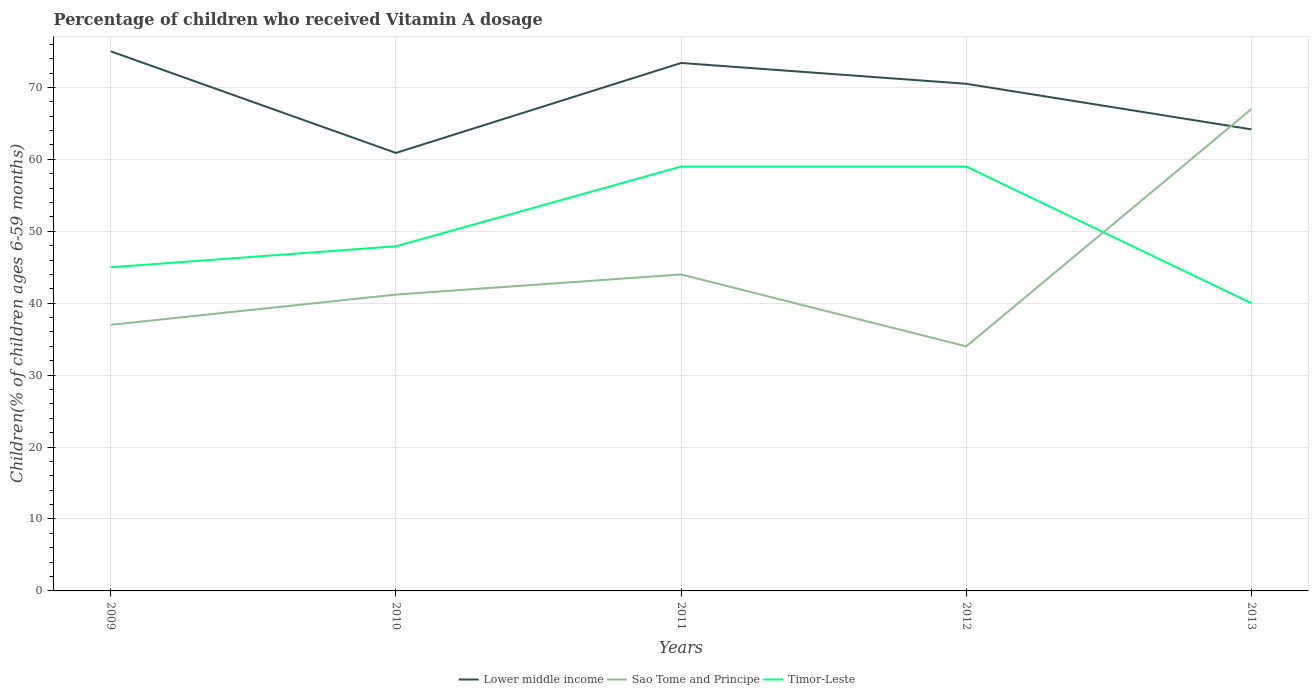Does the line corresponding to Sao Tome and Principe intersect with the line corresponding to Timor-Leste?
Ensure brevity in your answer.  Yes. In which year was the percentage of children who received Vitamin A dosage in Sao Tome and Principe maximum?
Your answer should be compact. 2012. What is the total percentage of children who received Vitamin A dosage in Timor-Leste in the graph?
Your answer should be very brief. 19. What is the difference between the highest and the second highest percentage of children who received Vitamin A dosage in Lower middle income?
Keep it short and to the point. 14.13. What is the difference between the highest and the lowest percentage of children who received Vitamin A dosage in Sao Tome and Principe?
Provide a succinct answer. 1. How many lines are there?
Offer a terse response. 3. What is the difference between two consecutive major ticks on the Y-axis?
Offer a very short reply. 10. Does the graph contain any zero values?
Offer a very short reply. No. Does the graph contain grids?
Give a very brief answer. Yes. How are the legend labels stacked?
Give a very brief answer. Horizontal. What is the title of the graph?
Keep it short and to the point. Percentage of children who received Vitamin A dosage. Does "Tanzania" appear as one of the legend labels in the graph?
Provide a short and direct response. No. What is the label or title of the X-axis?
Keep it short and to the point. Years. What is the label or title of the Y-axis?
Offer a terse response. Children(% of children ages 6-59 months). What is the Children(% of children ages 6-59 months) of Lower middle income in 2009?
Provide a short and direct response. 75.02. What is the Children(% of children ages 6-59 months) of Sao Tome and Principe in 2009?
Offer a very short reply. 37. What is the Children(% of children ages 6-59 months) of Lower middle income in 2010?
Provide a succinct answer. 60.9. What is the Children(% of children ages 6-59 months) of Sao Tome and Principe in 2010?
Give a very brief answer. 41.2. What is the Children(% of children ages 6-59 months) in Timor-Leste in 2010?
Your answer should be very brief. 47.91. What is the Children(% of children ages 6-59 months) in Lower middle income in 2011?
Your answer should be very brief. 73.4. What is the Children(% of children ages 6-59 months) in Sao Tome and Principe in 2011?
Keep it short and to the point. 44. What is the Children(% of children ages 6-59 months) of Lower middle income in 2012?
Give a very brief answer. 70.51. What is the Children(% of children ages 6-59 months) of Sao Tome and Principe in 2012?
Provide a succinct answer. 34. What is the Children(% of children ages 6-59 months) in Lower middle income in 2013?
Your response must be concise. 64.17. What is the Children(% of children ages 6-59 months) in Sao Tome and Principe in 2013?
Ensure brevity in your answer.  67. What is the Children(% of children ages 6-59 months) in Timor-Leste in 2013?
Keep it short and to the point. 40. Across all years, what is the maximum Children(% of children ages 6-59 months) in Lower middle income?
Your answer should be very brief. 75.02. Across all years, what is the minimum Children(% of children ages 6-59 months) in Lower middle income?
Provide a short and direct response. 60.9. Across all years, what is the minimum Children(% of children ages 6-59 months) in Sao Tome and Principe?
Keep it short and to the point. 34. What is the total Children(% of children ages 6-59 months) of Lower middle income in the graph?
Provide a succinct answer. 344.01. What is the total Children(% of children ages 6-59 months) in Sao Tome and Principe in the graph?
Make the answer very short. 223.2. What is the total Children(% of children ages 6-59 months) of Timor-Leste in the graph?
Provide a short and direct response. 250.91. What is the difference between the Children(% of children ages 6-59 months) in Lower middle income in 2009 and that in 2010?
Provide a succinct answer. 14.13. What is the difference between the Children(% of children ages 6-59 months) in Sao Tome and Principe in 2009 and that in 2010?
Your answer should be compact. -4.2. What is the difference between the Children(% of children ages 6-59 months) of Timor-Leste in 2009 and that in 2010?
Offer a very short reply. -2.91. What is the difference between the Children(% of children ages 6-59 months) in Lower middle income in 2009 and that in 2011?
Offer a terse response. 1.62. What is the difference between the Children(% of children ages 6-59 months) in Timor-Leste in 2009 and that in 2011?
Offer a terse response. -14. What is the difference between the Children(% of children ages 6-59 months) in Lower middle income in 2009 and that in 2012?
Provide a succinct answer. 4.51. What is the difference between the Children(% of children ages 6-59 months) in Timor-Leste in 2009 and that in 2012?
Provide a succinct answer. -14. What is the difference between the Children(% of children ages 6-59 months) in Lower middle income in 2009 and that in 2013?
Keep it short and to the point. 10.85. What is the difference between the Children(% of children ages 6-59 months) in Sao Tome and Principe in 2009 and that in 2013?
Give a very brief answer. -30. What is the difference between the Children(% of children ages 6-59 months) in Lower middle income in 2010 and that in 2011?
Keep it short and to the point. -12.51. What is the difference between the Children(% of children ages 6-59 months) of Sao Tome and Principe in 2010 and that in 2011?
Offer a terse response. -2.8. What is the difference between the Children(% of children ages 6-59 months) in Timor-Leste in 2010 and that in 2011?
Provide a succinct answer. -11.09. What is the difference between the Children(% of children ages 6-59 months) in Lower middle income in 2010 and that in 2012?
Provide a short and direct response. -9.62. What is the difference between the Children(% of children ages 6-59 months) in Sao Tome and Principe in 2010 and that in 2012?
Keep it short and to the point. 7.2. What is the difference between the Children(% of children ages 6-59 months) in Timor-Leste in 2010 and that in 2012?
Your answer should be very brief. -11.09. What is the difference between the Children(% of children ages 6-59 months) of Lower middle income in 2010 and that in 2013?
Ensure brevity in your answer.  -3.28. What is the difference between the Children(% of children ages 6-59 months) of Sao Tome and Principe in 2010 and that in 2013?
Make the answer very short. -25.8. What is the difference between the Children(% of children ages 6-59 months) of Timor-Leste in 2010 and that in 2013?
Make the answer very short. 7.91. What is the difference between the Children(% of children ages 6-59 months) of Lower middle income in 2011 and that in 2012?
Give a very brief answer. 2.89. What is the difference between the Children(% of children ages 6-59 months) of Lower middle income in 2011 and that in 2013?
Your response must be concise. 9.23. What is the difference between the Children(% of children ages 6-59 months) of Timor-Leste in 2011 and that in 2013?
Provide a succinct answer. 19. What is the difference between the Children(% of children ages 6-59 months) in Lower middle income in 2012 and that in 2013?
Your answer should be very brief. 6.34. What is the difference between the Children(% of children ages 6-59 months) of Sao Tome and Principe in 2012 and that in 2013?
Make the answer very short. -33. What is the difference between the Children(% of children ages 6-59 months) of Timor-Leste in 2012 and that in 2013?
Your answer should be compact. 19. What is the difference between the Children(% of children ages 6-59 months) of Lower middle income in 2009 and the Children(% of children ages 6-59 months) of Sao Tome and Principe in 2010?
Offer a very short reply. 33.82. What is the difference between the Children(% of children ages 6-59 months) in Lower middle income in 2009 and the Children(% of children ages 6-59 months) in Timor-Leste in 2010?
Make the answer very short. 27.11. What is the difference between the Children(% of children ages 6-59 months) in Sao Tome and Principe in 2009 and the Children(% of children ages 6-59 months) in Timor-Leste in 2010?
Make the answer very short. -10.91. What is the difference between the Children(% of children ages 6-59 months) of Lower middle income in 2009 and the Children(% of children ages 6-59 months) of Sao Tome and Principe in 2011?
Offer a very short reply. 31.02. What is the difference between the Children(% of children ages 6-59 months) in Lower middle income in 2009 and the Children(% of children ages 6-59 months) in Timor-Leste in 2011?
Offer a very short reply. 16.02. What is the difference between the Children(% of children ages 6-59 months) of Sao Tome and Principe in 2009 and the Children(% of children ages 6-59 months) of Timor-Leste in 2011?
Your response must be concise. -22. What is the difference between the Children(% of children ages 6-59 months) of Lower middle income in 2009 and the Children(% of children ages 6-59 months) of Sao Tome and Principe in 2012?
Give a very brief answer. 41.02. What is the difference between the Children(% of children ages 6-59 months) in Lower middle income in 2009 and the Children(% of children ages 6-59 months) in Timor-Leste in 2012?
Your answer should be very brief. 16.02. What is the difference between the Children(% of children ages 6-59 months) in Sao Tome and Principe in 2009 and the Children(% of children ages 6-59 months) in Timor-Leste in 2012?
Offer a very short reply. -22. What is the difference between the Children(% of children ages 6-59 months) of Lower middle income in 2009 and the Children(% of children ages 6-59 months) of Sao Tome and Principe in 2013?
Keep it short and to the point. 8.02. What is the difference between the Children(% of children ages 6-59 months) of Lower middle income in 2009 and the Children(% of children ages 6-59 months) of Timor-Leste in 2013?
Ensure brevity in your answer.  35.02. What is the difference between the Children(% of children ages 6-59 months) of Sao Tome and Principe in 2009 and the Children(% of children ages 6-59 months) of Timor-Leste in 2013?
Keep it short and to the point. -3. What is the difference between the Children(% of children ages 6-59 months) of Lower middle income in 2010 and the Children(% of children ages 6-59 months) of Sao Tome and Principe in 2011?
Your answer should be very brief. 16.9. What is the difference between the Children(% of children ages 6-59 months) in Lower middle income in 2010 and the Children(% of children ages 6-59 months) in Timor-Leste in 2011?
Keep it short and to the point. 1.9. What is the difference between the Children(% of children ages 6-59 months) of Sao Tome and Principe in 2010 and the Children(% of children ages 6-59 months) of Timor-Leste in 2011?
Provide a short and direct response. -17.8. What is the difference between the Children(% of children ages 6-59 months) of Lower middle income in 2010 and the Children(% of children ages 6-59 months) of Sao Tome and Principe in 2012?
Offer a terse response. 26.9. What is the difference between the Children(% of children ages 6-59 months) in Lower middle income in 2010 and the Children(% of children ages 6-59 months) in Timor-Leste in 2012?
Keep it short and to the point. 1.9. What is the difference between the Children(% of children ages 6-59 months) in Sao Tome and Principe in 2010 and the Children(% of children ages 6-59 months) in Timor-Leste in 2012?
Offer a terse response. -17.8. What is the difference between the Children(% of children ages 6-59 months) in Lower middle income in 2010 and the Children(% of children ages 6-59 months) in Sao Tome and Principe in 2013?
Keep it short and to the point. -6.1. What is the difference between the Children(% of children ages 6-59 months) in Lower middle income in 2010 and the Children(% of children ages 6-59 months) in Timor-Leste in 2013?
Make the answer very short. 20.9. What is the difference between the Children(% of children ages 6-59 months) in Sao Tome and Principe in 2010 and the Children(% of children ages 6-59 months) in Timor-Leste in 2013?
Ensure brevity in your answer.  1.2. What is the difference between the Children(% of children ages 6-59 months) in Lower middle income in 2011 and the Children(% of children ages 6-59 months) in Sao Tome and Principe in 2012?
Offer a terse response. 39.4. What is the difference between the Children(% of children ages 6-59 months) of Lower middle income in 2011 and the Children(% of children ages 6-59 months) of Timor-Leste in 2012?
Your response must be concise. 14.4. What is the difference between the Children(% of children ages 6-59 months) of Sao Tome and Principe in 2011 and the Children(% of children ages 6-59 months) of Timor-Leste in 2012?
Keep it short and to the point. -15. What is the difference between the Children(% of children ages 6-59 months) of Lower middle income in 2011 and the Children(% of children ages 6-59 months) of Sao Tome and Principe in 2013?
Your answer should be compact. 6.4. What is the difference between the Children(% of children ages 6-59 months) of Lower middle income in 2011 and the Children(% of children ages 6-59 months) of Timor-Leste in 2013?
Your response must be concise. 33.4. What is the difference between the Children(% of children ages 6-59 months) in Lower middle income in 2012 and the Children(% of children ages 6-59 months) in Sao Tome and Principe in 2013?
Give a very brief answer. 3.51. What is the difference between the Children(% of children ages 6-59 months) of Lower middle income in 2012 and the Children(% of children ages 6-59 months) of Timor-Leste in 2013?
Ensure brevity in your answer.  30.51. What is the difference between the Children(% of children ages 6-59 months) of Sao Tome and Principe in 2012 and the Children(% of children ages 6-59 months) of Timor-Leste in 2013?
Provide a short and direct response. -6. What is the average Children(% of children ages 6-59 months) in Lower middle income per year?
Keep it short and to the point. 68.8. What is the average Children(% of children ages 6-59 months) of Sao Tome and Principe per year?
Your answer should be compact. 44.64. What is the average Children(% of children ages 6-59 months) in Timor-Leste per year?
Make the answer very short. 50.18. In the year 2009, what is the difference between the Children(% of children ages 6-59 months) of Lower middle income and Children(% of children ages 6-59 months) of Sao Tome and Principe?
Offer a terse response. 38.02. In the year 2009, what is the difference between the Children(% of children ages 6-59 months) in Lower middle income and Children(% of children ages 6-59 months) in Timor-Leste?
Give a very brief answer. 30.02. In the year 2009, what is the difference between the Children(% of children ages 6-59 months) of Sao Tome and Principe and Children(% of children ages 6-59 months) of Timor-Leste?
Give a very brief answer. -8. In the year 2010, what is the difference between the Children(% of children ages 6-59 months) in Lower middle income and Children(% of children ages 6-59 months) in Sao Tome and Principe?
Provide a short and direct response. 19.69. In the year 2010, what is the difference between the Children(% of children ages 6-59 months) of Lower middle income and Children(% of children ages 6-59 months) of Timor-Leste?
Provide a succinct answer. 12.98. In the year 2010, what is the difference between the Children(% of children ages 6-59 months) in Sao Tome and Principe and Children(% of children ages 6-59 months) in Timor-Leste?
Your response must be concise. -6.71. In the year 2011, what is the difference between the Children(% of children ages 6-59 months) in Lower middle income and Children(% of children ages 6-59 months) in Sao Tome and Principe?
Provide a succinct answer. 29.4. In the year 2011, what is the difference between the Children(% of children ages 6-59 months) of Lower middle income and Children(% of children ages 6-59 months) of Timor-Leste?
Ensure brevity in your answer.  14.4. In the year 2011, what is the difference between the Children(% of children ages 6-59 months) in Sao Tome and Principe and Children(% of children ages 6-59 months) in Timor-Leste?
Ensure brevity in your answer.  -15. In the year 2012, what is the difference between the Children(% of children ages 6-59 months) in Lower middle income and Children(% of children ages 6-59 months) in Sao Tome and Principe?
Keep it short and to the point. 36.51. In the year 2012, what is the difference between the Children(% of children ages 6-59 months) in Lower middle income and Children(% of children ages 6-59 months) in Timor-Leste?
Give a very brief answer. 11.51. In the year 2013, what is the difference between the Children(% of children ages 6-59 months) of Lower middle income and Children(% of children ages 6-59 months) of Sao Tome and Principe?
Make the answer very short. -2.83. In the year 2013, what is the difference between the Children(% of children ages 6-59 months) in Lower middle income and Children(% of children ages 6-59 months) in Timor-Leste?
Offer a terse response. 24.17. In the year 2013, what is the difference between the Children(% of children ages 6-59 months) in Sao Tome and Principe and Children(% of children ages 6-59 months) in Timor-Leste?
Your answer should be very brief. 27. What is the ratio of the Children(% of children ages 6-59 months) of Lower middle income in 2009 to that in 2010?
Give a very brief answer. 1.23. What is the ratio of the Children(% of children ages 6-59 months) of Sao Tome and Principe in 2009 to that in 2010?
Offer a terse response. 0.9. What is the ratio of the Children(% of children ages 6-59 months) in Timor-Leste in 2009 to that in 2010?
Offer a terse response. 0.94. What is the ratio of the Children(% of children ages 6-59 months) in Lower middle income in 2009 to that in 2011?
Ensure brevity in your answer.  1.02. What is the ratio of the Children(% of children ages 6-59 months) in Sao Tome and Principe in 2009 to that in 2011?
Ensure brevity in your answer.  0.84. What is the ratio of the Children(% of children ages 6-59 months) of Timor-Leste in 2009 to that in 2011?
Keep it short and to the point. 0.76. What is the ratio of the Children(% of children ages 6-59 months) of Lower middle income in 2009 to that in 2012?
Ensure brevity in your answer.  1.06. What is the ratio of the Children(% of children ages 6-59 months) of Sao Tome and Principe in 2009 to that in 2012?
Your response must be concise. 1.09. What is the ratio of the Children(% of children ages 6-59 months) in Timor-Leste in 2009 to that in 2012?
Your response must be concise. 0.76. What is the ratio of the Children(% of children ages 6-59 months) in Lower middle income in 2009 to that in 2013?
Make the answer very short. 1.17. What is the ratio of the Children(% of children ages 6-59 months) of Sao Tome and Principe in 2009 to that in 2013?
Your answer should be very brief. 0.55. What is the ratio of the Children(% of children ages 6-59 months) of Lower middle income in 2010 to that in 2011?
Your answer should be compact. 0.83. What is the ratio of the Children(% of children ages 6-59 months) in Sao Tome and Principe in 2010 to that in 2011?
Provide a succinct answer. 0.94. What is the ratio of the Children(% of children ages 6-59 months) in Timor-Leste in 2010 to that in 2011?
Provide a short and direct response. 0.81. What is the ratio of the Children(% of children ages 6-59 months) in Lower middle income in 2010 to that in 2012?
Keep it short and to the point. 0.86. What is the ratio of the Children(% of children ages 6-59 months) in Sao Tome and Principe in 2010 to that in 2012?
Provide a succinct answer. 1.21. What is the ratio of the Children(% of children ages 6-59 months) of Timor-Leste in 2010 to that in 2012?
Offer a very short reply. 0.81. What is the ratio of the Children(% of children ages 6-59 months) in Lower middle income in 2010 to that in 2013?
Offer a very short reply. 0.95. What is the ratio of the Children(% of children ages 6-59 months) of Sao Tome and Principe in 2010 to that in 2013?
Give a very brief answer. 0.61. What is the ratio of the Children(% of children ages 6-59 months) in Timor-Leste in 2010 to that in 2013?
Offer a terse response. 1.2. What is the ratio of the Children(% of children ages 6-59 months) of Lower middle income in 2011 to that in 2012?
Make the answer very short. 1.04. What is the ratio of the Children(% of children ages 6-59 months) of Sao Tome and Principe in 2011 to that in 2012?
Make the answer very short. 1.29. What is the ratio of the Children(% of children ages 6-59 months) of Timor-Leste in 2011 to that in 2012?
Ensure brevity in your answer.  1. What is the ratio of the Children(% of children ages 6-59 months) in Lower middle income in 2011 to that in 2013?
Offer a terse response. 1.14. What is the ratio of the Children(% of children ages 6-59 months) of Sao Tome and Principe in 2011 to that in 2013?
Offer a terse response. 0.66. What is the ratio of the Children(% of children ages 6-59 months) of Timor-Leste in 2011 to that in 2013?
Your answer should be compact. 1.48. What is the ratio of the Children(% of children ages 6-59 months) of Lower middle income in 2012 to that in 2013?
Ensure brevity in your answer.  1.1. What is the ratio of the Children(% of children ages 6-59 months) in Sao Tome and Principe in 2012 to that in 2013?
Give a very brief answer. 0.51. What is the ratio of the Children(% of children ages 6-59 months) in Timor-Leste in 2012 to that in 2013?
Keep it short and to the point. 1.48. What is the difference between the highest and the second highest Children(% of children ages 6-59 months) in Lower middle income?
Offer a terse response. 1.62. What is the difference between the highest and the second highest Children(% of children ages 6-59 months) of Sao Tome and Principe?
Give a very brief answer. 23. What is the difference between the highest and the second highest Children(% of children ages 6-59 months) in Timor-Leste?
Your answer should be very brief. 0. What is the difference between the highest and the lowest Children(% of children ages 6-59 months) in Lower middle income?
Your answer should be compact. 14.13. What is the difference between the highest and the lowest Children(% of children ages 6-59 months) in Sao Tome and Principe?
Provide a short and direct response. 33. What is the difference between the highest and the lowest Children(% of children ages 6-59 months) in Timor-Leste?
Offer a very short reply. 19. 